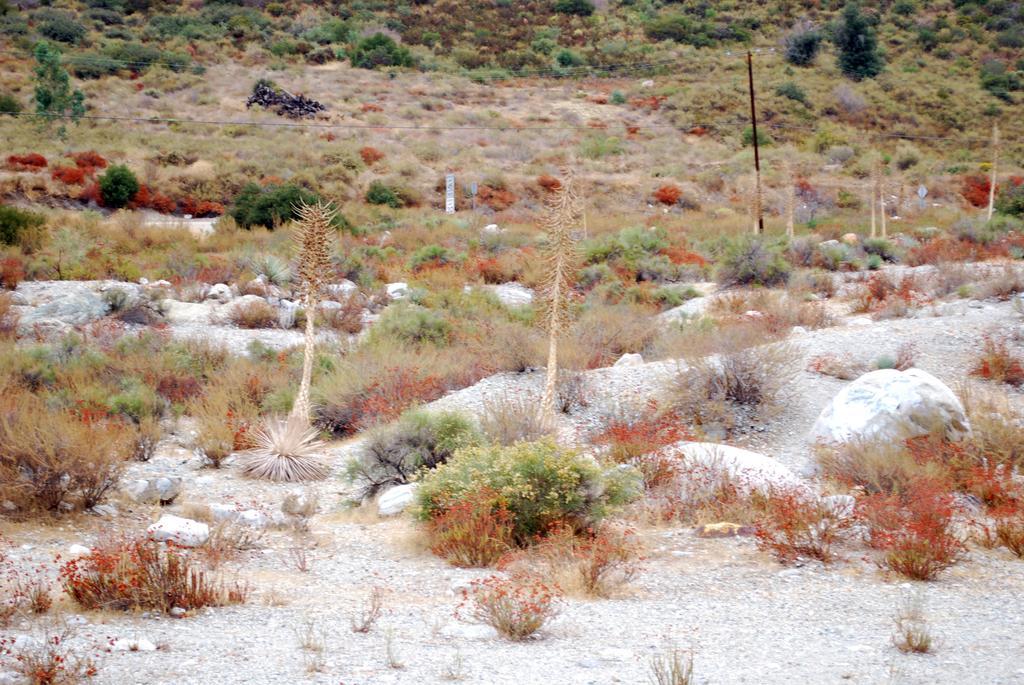Can you describe this image briefly? In this image we can see plants, stones. there is a pole. At the bottom of the image there is ground. 